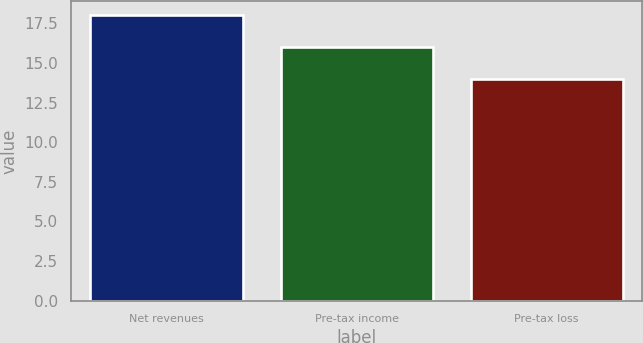Convert chart to OTSL. <chart><loc_0><loc_0><loc_500><loc_500><bar_chart><fcel>Net revenues<fcel>Pre-tax income<fcel>Pre-tax loss<nl><fcel>18<fcel>16<fcel>14<nl></chart> 